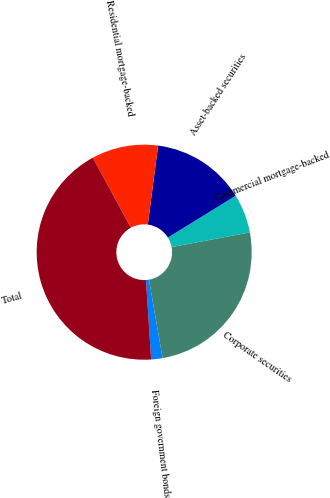Convert chart. <chart><loc_0><loc_0><loc_500><loc_500><pie_chart><fcel>Foreign government bonds<fcel>Corporate securities<fcel>Commercial mortgage-backed<fcel>Asset-backed securities<fcel>Residential mortgage-backed<fcel>Total<nl><fcel>1.71%<fcel>25.21%<fcel>5.85%<fcel>14.13%<fcel>9.99%<fcel>43.11%<nl></chart> 